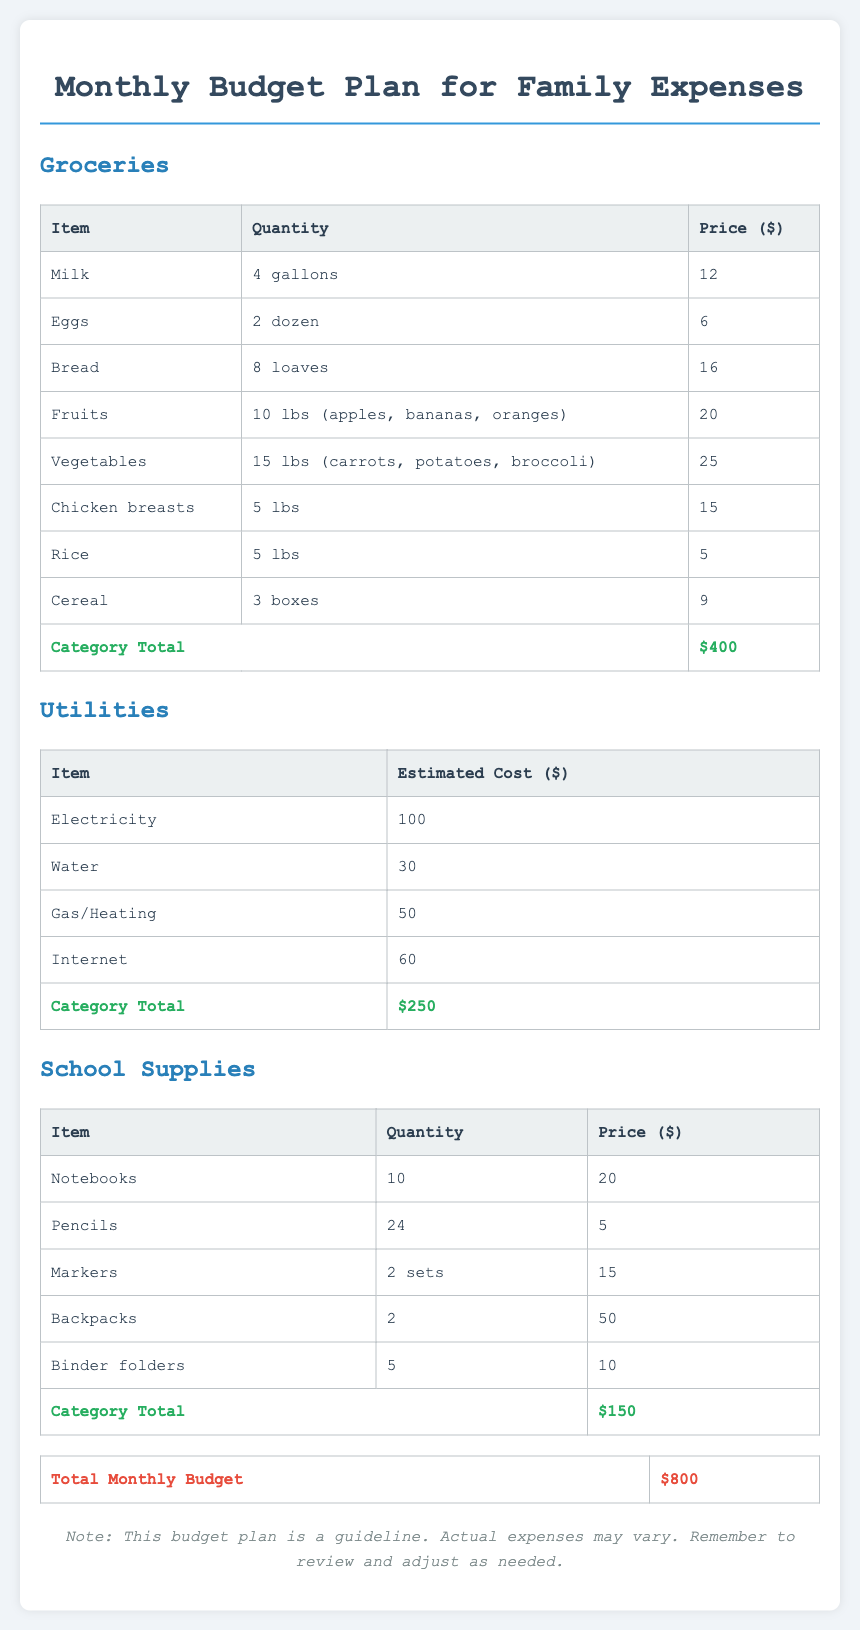What is the category total for Groceries? The category total for Groceries is found at the end of the section, which is $400.
Answer: $400 What is the estimated cost for Water? The estimated cost for Water is listed under the Utilities section, specifically as $30.
Answer: $30 How many gallons of Milk are included in the grocery list? The grocery list specifies the quantity of Milk as 4 gallons.
Answer: 4 gallons What is the total monthly budget for family expenses? The total monthly budget is summarized at the end of the document, which is $800.
Answer: $800 How much is allocated for school supplies? The category total for School Supplies is indicated as $150.
Answer: $150 Which grocery item costs $25? The document lists Vegetables as the item costing $25.
Answer: Vegetables What is the quantity of Backpacks needed? The quantity of Backpacks needed is stated as 2.
Answer: 2 What is the total cost of Electricity? The cost of Electricity under the Utilities section is provided as $100.
Answer: $100 How many boxes of Cereal are included? The document specifies that there are 3 boxes of Cereal included in the grocery list.
Answer: 3 boxes 